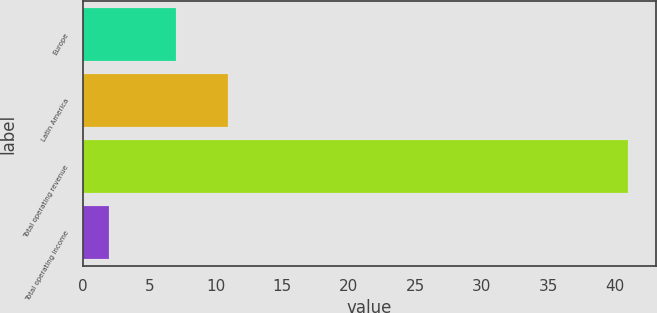Convert chart. <chart><loc_0><loc_0><loc_500><loc_500><bar_chart><fcel>Europe<fcel>Latin America<fcel>Total operating revenue<fcel>Total operating income<nl><fcel>7<fcel>10.9<fcel>41<fcel>2<nl></chart> 